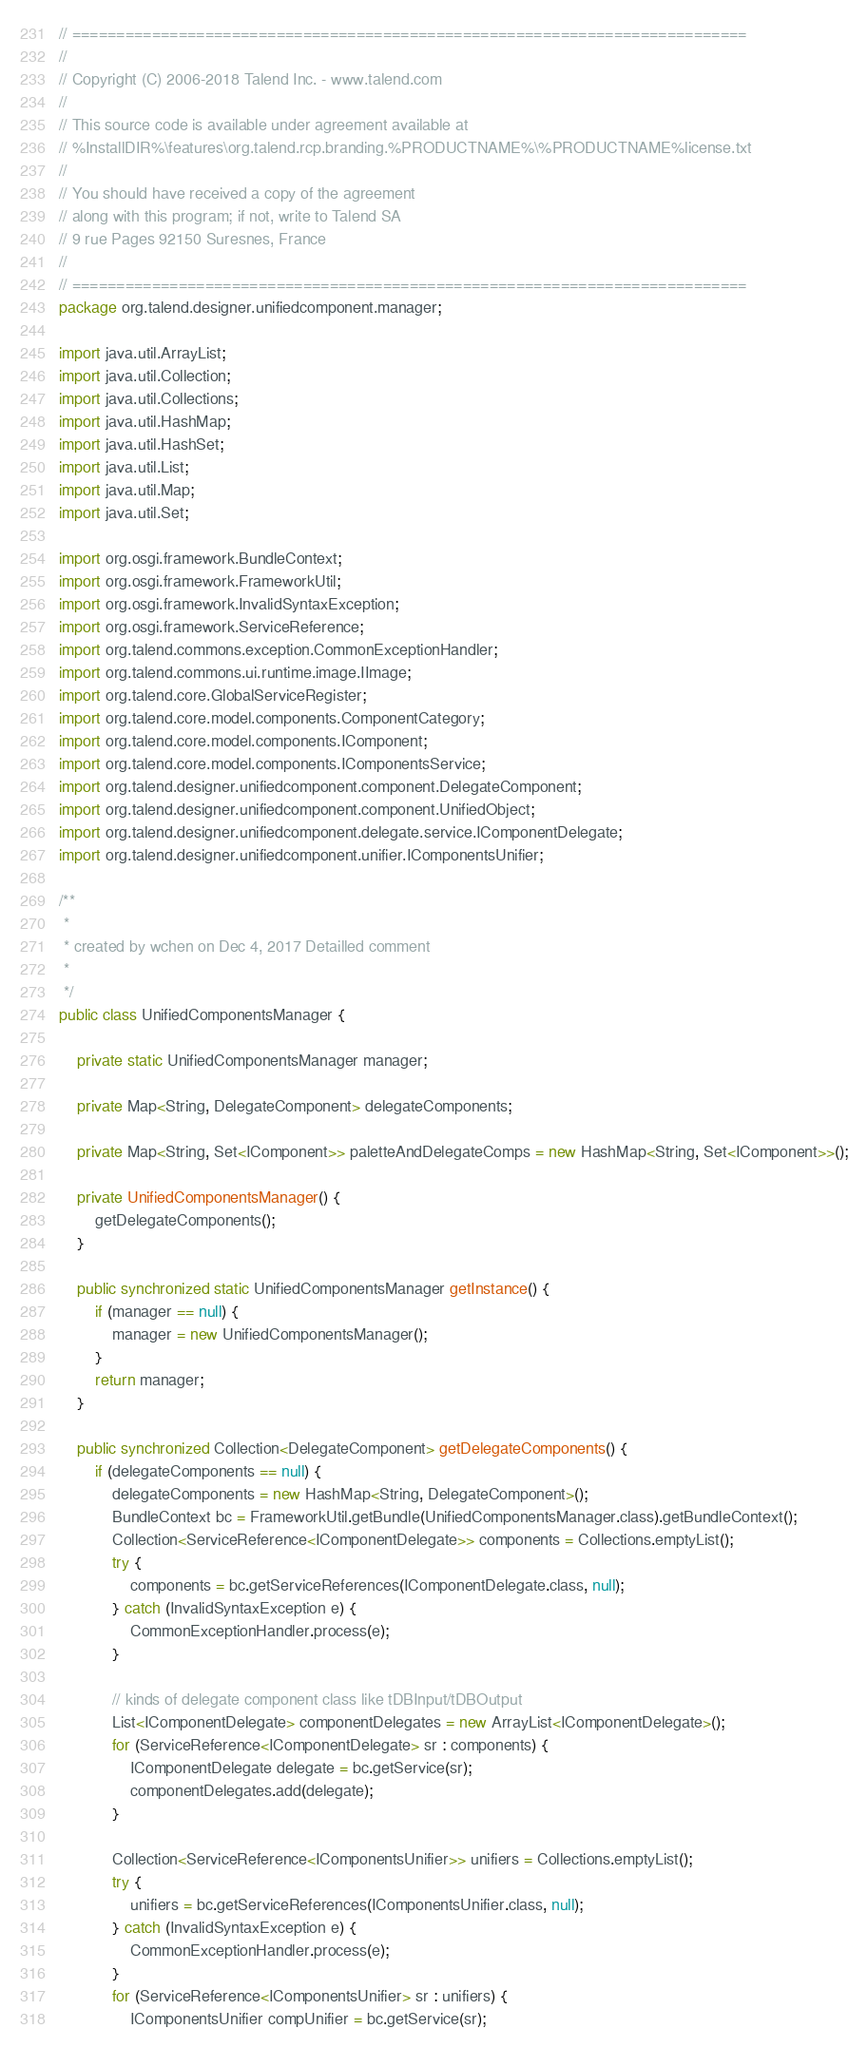<code> <loc_0><loc_0><loc_500><loc_500><_Java_>// ============================================================================
//
// Copyright (C) 2006-2018 Talend Inc. - www.talend.com
//
// This source code is available under agreement available at
// %InstallDIR%\features\org.talend.rcp.branding.%PRODUCTNAME%\%PRODUCTNAME%license.txt
//
// You should have received a copy of the agreement
// along with this program; if not, write to Talend SA
// 9 rue Pages 92150 Suresnes, France
//
// ============================================================================
package org.talend.designer.unifiedcomponent.manager;

import java.util.ArrayList;
import java.util.Collection;
import java.util.Collections;
import java.util.HashMap;
import java.util.HashSet;
import java.util.List;
import java.util.Map;
import java.util.Set;

import org.osgi.framework.BundleContext;
import org.osgi.framework.FrameworkUtil;
import org.osgi.framework.InvalidSyntaxException;
import org.osgi.framework.ServiceReference;
import org.talend.commons.exception.CommonExceptionHandler;
import org.talend.commons.ui.runtime.image.IImage;
import org.talend.core.GlobalServiceRegister;
import org.talend.core.model.components.ComponentCategory;
import org.talend.core.model.components.IComponent;
import org.talend.core.model.components.IComponentsService;
import org.talend.designer.unifiedcomponent.component.DelegateComponent;
import org.talend.designer.unifiedcomponent.component.UnifiedObject;
import org.talend.designer.unifiedcomponent.delegate.service.IComponentDelegate;
import org.talend.designer.unifiedcomponent.unifier.IComponentsUnifier;

/**
 * 
 * created by wchen on Dec 4, 2017 Detailled comment
 *
 */
public class UnifiedComponentsManager {

    private static UnifiedComponentsManager manager;

    private Map<String, DelegateComponent> delegateComponents;

    private Map<String, Set<IComponent>> paletteAndDelegateComps = new HashMap<String, Set<IComponent>>();

    private UnifiedComponentsManager() {
        getDelegateComponents();
    }

    public synchronized static UnifiedComponentsManager getInstance() {
        if (manager == null) {
            manager = new UnifiedComponentsManager();
        }
        return manager;
    }

    public synchronized Collection<DelegateComponent> getDelegateComponents() {
        if (delegateComponents == null) {
            delegateComponents = new HashMap<String, DelegateComponent>();
            BundleContext bc = FrameworkUtil.getBundle(UnifiedComponentsManager.class).getBundleContext();
            Collection<ServiceReference<IComponentDelegate>> components = Collections.emptyList();
            try {
                components = bc.getServiceReferences(IComponentDelegate.class, null);
            } catch (InvalidSyntaxException e) {
                CommonExceptionHandler.process(e);
            }

            // kinds of delegate component class like tDBInput/tDBOutput
            List<IComponentDelegate> componentDelegates = new ArrayList<IComponentDelegate>();
            for (ServiceReference<IComponentDelegate> sr : components) {
                IComponentDelegate delegate = bc.getService(sr);
                componentDelegates.add(delegate);
            }

            Collection<ServiceReference<IComponentsUnifier>> unifiers = Collections.emptyList();
            try {
                unifiers = bc.getServiceReferences(IComponentsUnifier.class, null);
            } catch (InvalidSyntaxException e) {
                CommonExceptionHandler.process(e);
            }
            for (ServiceReference<IComponentsUnifier> sr : unifiers) {
                IComponentsUnifier compUnifier = bc.getService(sr);</code> 